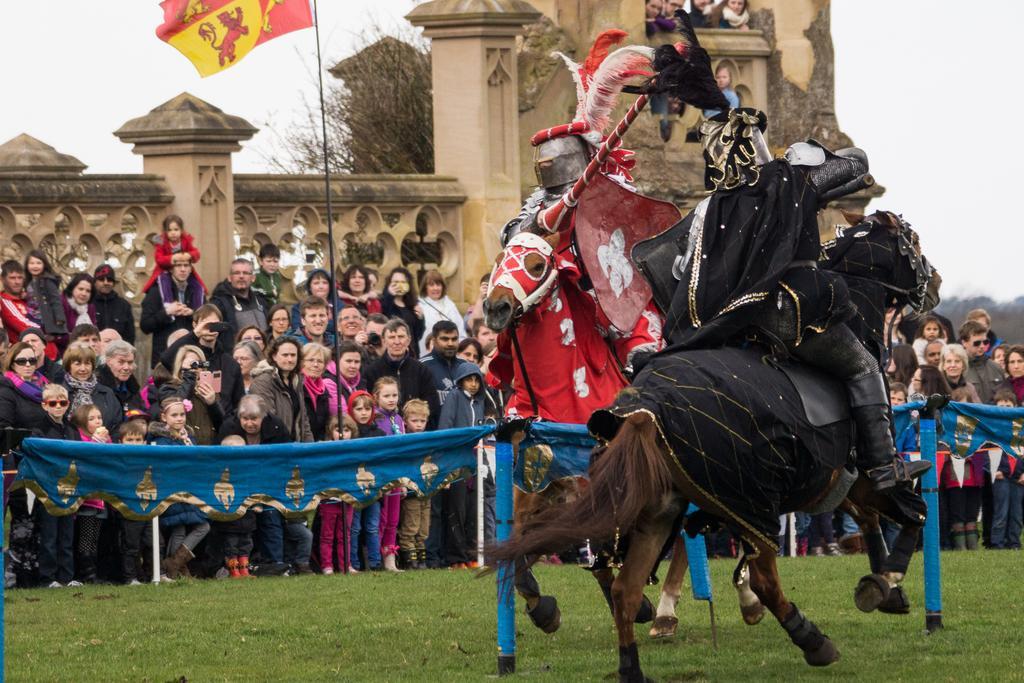In one or two sentences, can you explain what this image depicts? In this image there is the sky towards the top of the image, there is a wall, there is a tree, there is a pole, there is a flag towards the top of the image, there are group of audience, there is a cloth tied to poles, there are two horses, there are two men sitting on horses, they are holding an object, there is an object towards the right of the image, there is grass towards the bottom of the image. 